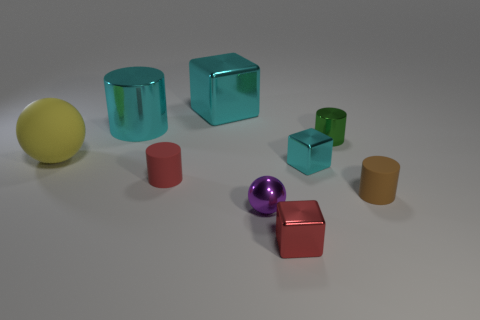What materials are the objects made of? The objects in the image seem to be made of different materials. The shiny surfaces on the red cube and the purple sphere suggest that they could be made of a reflective metal or plastic, while the matte surfaces on the other shapes indicate they could be made of a diffuse material like rubber or a non-glossy plastic. 